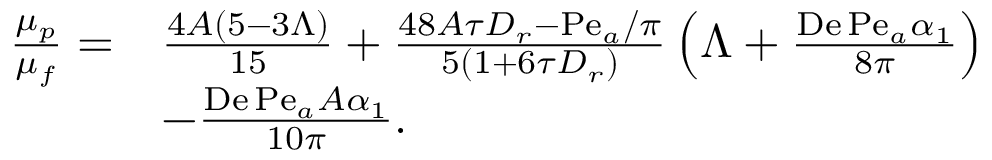Convert formula to latex. <formula><loc_0><loc_0><loc_500><loc_500>\begin{array} { r l } { \frac { \mu _ { p } } { \mu _ { f } } = } & { \frac { 4 A ( 5 - 3 \Lambda ) } { 1 5 } + \frac { 4 8 A \tau D _ { r } - P e _ { a } / \pi } { 5 \left ( 1 + 6 \tau D _ { r } \right ) } \left ( \Lambda + \frac { D e \, P e _ { a } \alpha _ { 1 } } { 8 \pi } \right ) } \\ & { - \frac { D e \, P e _ { a } A \alpha _ { 1 } } { 1 0 \pi } . } \end{array}</formula> 